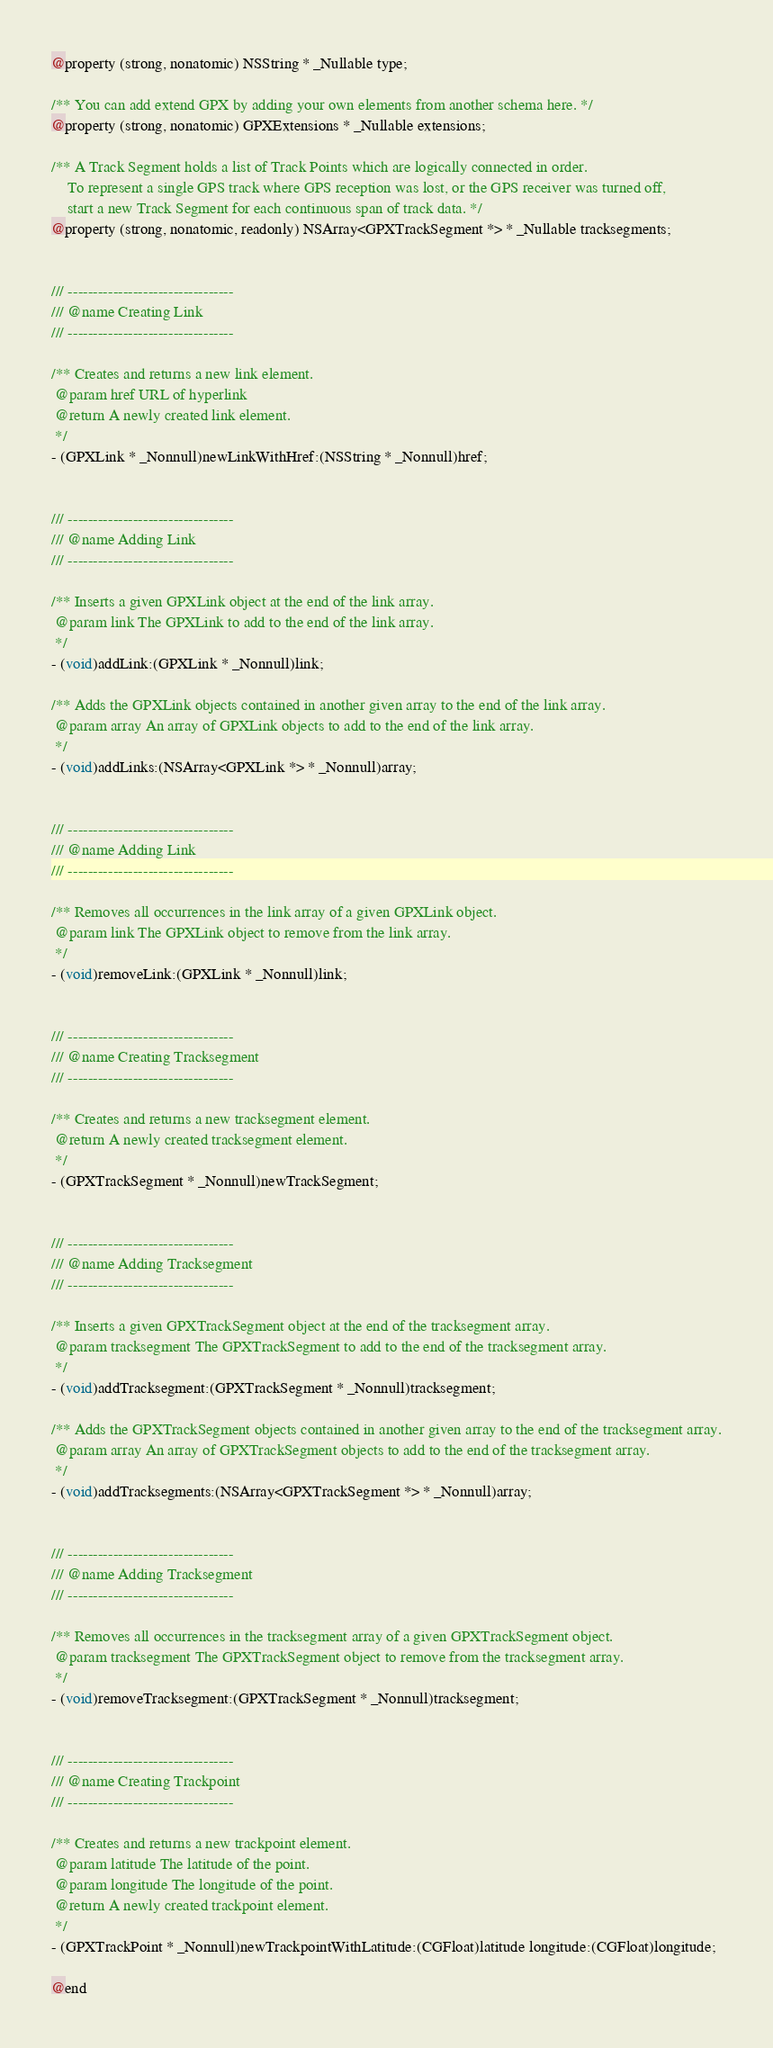<code> <loc_0><loc_0><loc_500><loc_500><_C_>@property (strong, nonatomic) NSString * _Nullable type;

/** You can add extend GPX by adding your own elements from another schema here. */
@property (strong, nonatomic) GPXExtensions * _Nullable extensions;

/** A Track Segment holds a list of Track Points which are logically connected in order.
    To represent a single GPS track where GPS reception was lost, or the GPS receiver was turned off, 
    start a new Track Segment for each continuous span of track data. */
@property (strong, nonatomic, readonly) NSArray<GPXTrackSegment *> * _Nullable tracksegments;


/// ---------------------------------
/// @name Creating Link
/// ---------------------------------

/** Creates and returns a new link element.
 @param href URL of hyperlink
 @return A newly created link element.
 */
- (GPXLink * _Nonnull)newLinkWithHref:(NSString * _Nonnull)href;


/// ---------------------------------
/// @name Adding Link
/// ---------------------------------

/** Inserts a given GPXLink object at the end of the link array.
 @param link The GPXLink to add to the end of the link array.
 */
- (void)addLink:(GPXLink * _Nonnull)link;

/** Adds the GPXLink objects contained in another given array to the end of the link array.
 @param array An array of GPXLink objects to add to the end of the link array.
 */
- (void)addLinks:(NSArray<GPXLink *> * _Nonnull)array;


/// ---------------------------------
/// @name Adding Link
/// ---------------------------------

/** Removes all occurrences in the link array of a given GPXLink object.
 @param link The GPXLink object to remove from the link array.
 */
- (void)removeLink:(GPXLink * _Nonnull)link;


/// ---------------------------------
/// @name Creating Tracksegment
/// ---------------------------------

/** Creates and returns a new tracksegment element.
 @return A newly created tracksegment element.
 */
- (GPXTrackSegment * _Nonnull)newTrackSegment;


/// ---------------------------------
/// @name Adding Tracksegment
/// ---------------------------------

/** Inserts a given GPXTrackSegment object at the end of the tracksegment array.
 @param tracksegment The GPXTrackSegment to add to the end of the tracksegment array.
 */
- (void)addTracksegment:(GPXTrackSegment * _Nonnull)tracksegment;

/** Adds the GPXTrackSegment objects contained in another given array to the end of the tracksegment array.
 @param array An array of GPXTrackSegment objects to add to the end of the tracksegment array.
 */
- (void)addTracksegments:(NSArray<GPXTrackSegment *> * _Nonnull)array;


/// ---------------------------------
/// @name Adding Tracksegment
/// ---------------------------------

/** Removes all occurrences in the tracksegment array of a given GPXTrackSegment object.
 @param tracksegment The GPXTrackSegment object to remove from the tracksegment array.
 */
- (void)removeTracksegment:(GPXTrackSegment * _Nonnull)tracksegment;


/// ---------------------------------
/// @name Creating Trackpoint
/// ---------------------------------

/** Creates and returns a new trackpoint element.
 @param latitude The latitude of the point.
 @param longitude The longitude of the point.
 @return A newly created trackpoint element.
 */
- (GPXTrackPoint * _Nonnull)newTrackpointWithLatitude:(CGFloat)latitude longitude:(CGFloat)longitude;

@end
</code> 